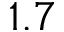<formula> <loc_0><loc_0><loc_500><loc_500>1 . 7</formula> 